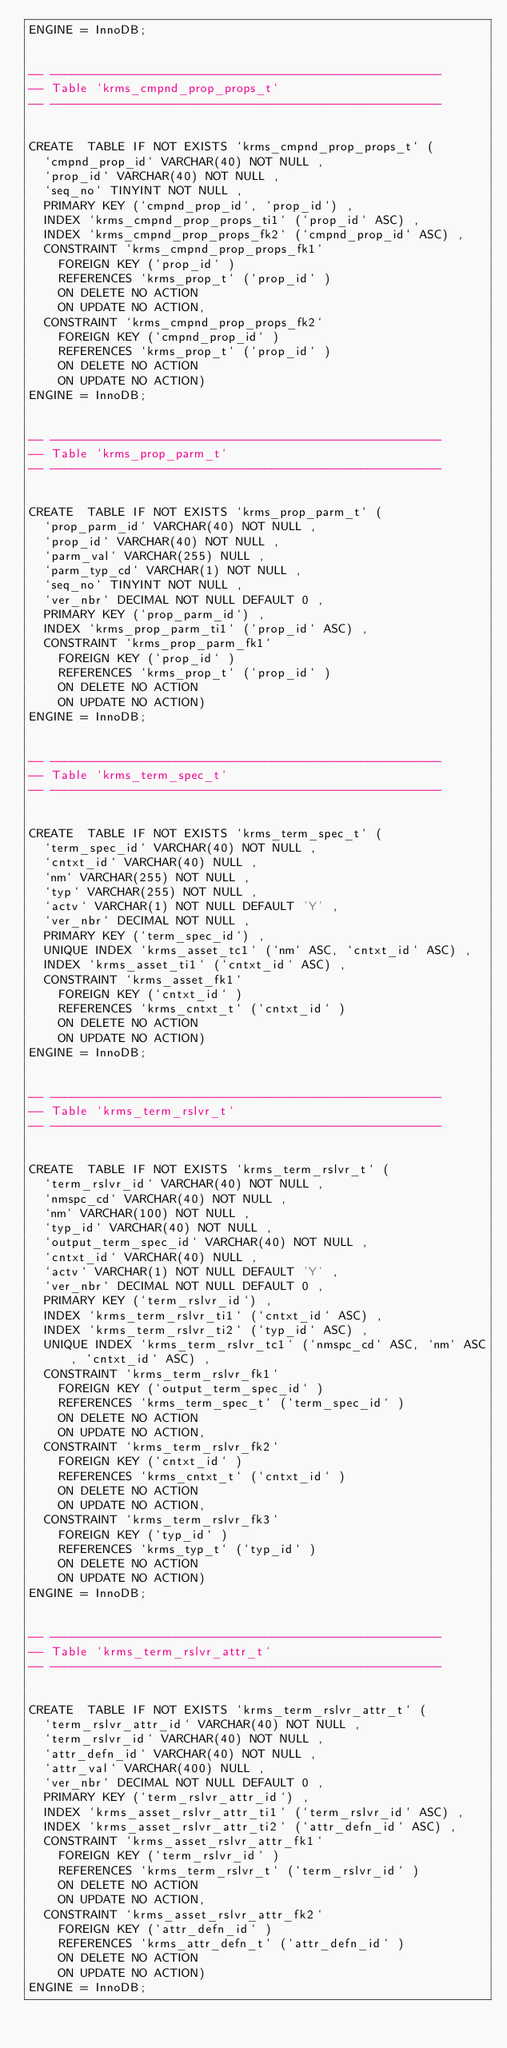<code> <loc_0><loc_0><loc_500><loc_500><_SQL_>ENGINE = InnoDB;


-- -----------------------------------------------------
-- Table `krms_cmpnd_prop_props_t`
-- -----------------------------------------------------


CREATE  TABLE IF NOT EXISTS `krms_cmpnd_prop_props_t` (
  `cmpnd_prop_id` VARCHAR(40) NOT NULL ,
  `prop_id` VARCHAR(40) NOT NULL ,
  `seq_no` TINYINT NOT NULL ,
  PRIMARY KEY (`cmpnd_prop_id`, `prop_id`) ,
  INDEX `krms_cmpnd_prop_props_ti1` (`prop_id` ASC) ,
  INDEX `krms_cmpnd_prop_props_fk2` (`cmpnd_prop_id` ASC) ,
  CONSTRAINT `krms_cmpnd_prop_props_fk1`
    FOREIGN KEY (`prop_id` )
    REFERENCES `krms_prop_t` (`prop_id` )
    ON DELETE NO ACTION
    ON UPDATE NO ACTION,
  CONSTRAINT `krms_cmpnd_prop_props_fk2`
    FOREIGN KEY (`cmpnd_prop_id` )
    REFERENCES `krms_prop_t` (`prop_id` )
    ON DELETE NO ACTION
    ON UPDATE NO ACTION)
ENGINE = InnoDB;


-- -----------------------------------------------------
-- Table `krms_prop_parm_t`
-- -----------------------------------------------------


CREATE  TABLE IF NOT EXISTS `krms_prop_parm_t` (
  `prop_parm_id` VARCHAR(40) NOT NULL ,
  `prop_id` VARCHAR(40) NOT NULL ,
  `parm_val` VARCHAR(255) NULL ,
  `parm_typ_cd` VARCHAR(1) NOT NULL ,
  `seq_no` TINYINT NOT NULL ,
  `ver_nbr` DECIMAL NOT NULL DEFAULT 0 ,
  PRIMARY KEY (`prop_parm_id`) ,
  INDEX `krms_prop_parm_ti1` (`prop_id` ASC) ,
  CONSTRAINT `krms_prop_parm_fk1`
    FOREIGN KEY (`prop_id` )
    REFERENCES `krms_prop_t` (`prop_id` )
    ON DELETE NO ACTION
    ON UPDATE NO ACTION)
ENGINE = InnoDB;


-- -----------------------------------------------------
-- Table `krms_term_spec_t`
-- -----------------------------------------------------


CREATE  TABLE IF NOT EXISTS `krms_term_spec_t` (
  `term_spec_id` VARCHAR(40) NOT NULL ,
  `cntxt_id` VARCHAR(40) NULL ,
  `nm` VARCHAR(255) NOT NULL ,
  `typ` VARCHAR(255) NOT NULL ,
  `actv` VARCHAR(1) NOT NULL DEFAULT 'Y' ,
  `ver_nbr` DECIMAL NOT NULL ,
  PRIMARY KEY (`term_spec_id`) ,
  UNIQUE INDEX `krms_asset_tc1` (`nm` ASC, `cntxt_id` ASC) ,
  INDEX `krms_asset_ti1` (`cntxt_id` ASC) ,
  CONSTRAINT `krms_asset_fk1`
    FOREIGN KEY (`cntxt_id` )
    REFERENCES `krms_cntxt_t` (`cntxt_id` )
    ON DELETE NO ACTION
    ON UPDATE NO ACTION)
ENGINE = InnoDB;


-- -----------------------------------------------------
-- Table `krms_term_rslvr_t`
-- -----------------------------------------------------


CREATE  TABLE IF NOT EXISTS `krms_term_rslvr_t` (
  `term_rslvr_id` VARCHAR(40) NOT NULL ,
  `nmspc_cd` VARCHAR(40) NOT NULL ,
  `nm` VARCHAR(100) NOT NULL ,
  `typ_id` VARCHAR(40) NOT NULL ,
  `output_term_spec_id` VARCHAR(40) NOT NULL ,
  `cntxt_id` VARCHAR(40) NULL ,
  `actv` VARCHAR(1) NOT NULL DEFAULT 'Y' ,
  `ver_nbr` DECIMAL NOT NULL DEFAULT 0 ,
  PRIMARY KEY (`term_rslvr_id`) ,
  INDEX `krms_term_rslvr_ti1` (`cntxt_id` ASC) ,
  INDEX `krms_term_rslvr_ti2` (`typ_id` ASC) ,
  UNIQUE INDEX `krms_term_rslvr_tc1` (`nmspc_cd` ASC, `nm` ASC, `cntxt_id` ASC) ,
  CONSTRAINT `krms_term_rslvr_fk1`
    FOREIGN KEY (`output_term_spec_id` )
    REFERENCES `krms_term_spec_t` (`term_spec_id` )
    ON DELETE NO ACTION
    ON UPDATE NO ACTION,
  CONSTRAINT `krms_term_rslvr_fk2`
    FOREIGN KEY (`cntxt_id` )
    REFERENCES `krms_cntxt_t` (`cntxt_id` )
    ON DELETE NO ACTION
    ON UPDATE NO ACTION,
  CONSTRAINT `krms_term_rslvr_fk3`
    FOREIGN KEY (`typ_id` )
    REFERENCES `krms_typ_t` (`typ_id` )
    ON DELETE NO ACTION
    ON UPDATE NO ACTION)
ENGINE = InnoDB;


-- -----------------------------------------------------
-- Table `krms_term_rslvr_attr_t`
-- -----------------------------------------------------


CREATE  TABLE IF NOT EXISTS `krms_term_rslvr_attr_t` (
  `term_rslvr_attr_id` VARCHAR(40) NOT NULL ,
  `term_rslvr_id` VARCHAR(40) NOT NULL ,
  `attr_defn_id` VARCHAR(40) NOT NULL ,
  `attr_val` VARCHAR(400) NULL ,
  `ver_nbr` DECIMAL NOT NULL DEFAULT 0 ,
  PRIMARY KEY (`term_rslvr_attr_id`) ,
  INDEX `krms_asset_rslvr_attr_ti1` (`term_rslvr_id` ASC) ,
  INDEX `krms_asset_rslvr_attr_ti2` (`attr_defn_id` ASC) ,
  CONSTRAINT `krms_asset_rslvr_attr_fk1`
    FOREIGN KEY (`term_rslvr_id` )
    REFERENCES `krms_term_rslvr_t` (`term_rslvr_id` )
    ON DELETE NO ACTION
    ON UPDATE NO ACTION,
  CONSTRAINT `krms_asset_rslvr_attr_fk2`
    FOREIGN KEY (`attr_defn_id` )
    REFERENCES `krms_attr_defn_t` (`attr_defn_id` )
    ON DELETE NO ACTION
    ON UPDATE NO ACTION)
ENGINE = InnoDB;

</code> 